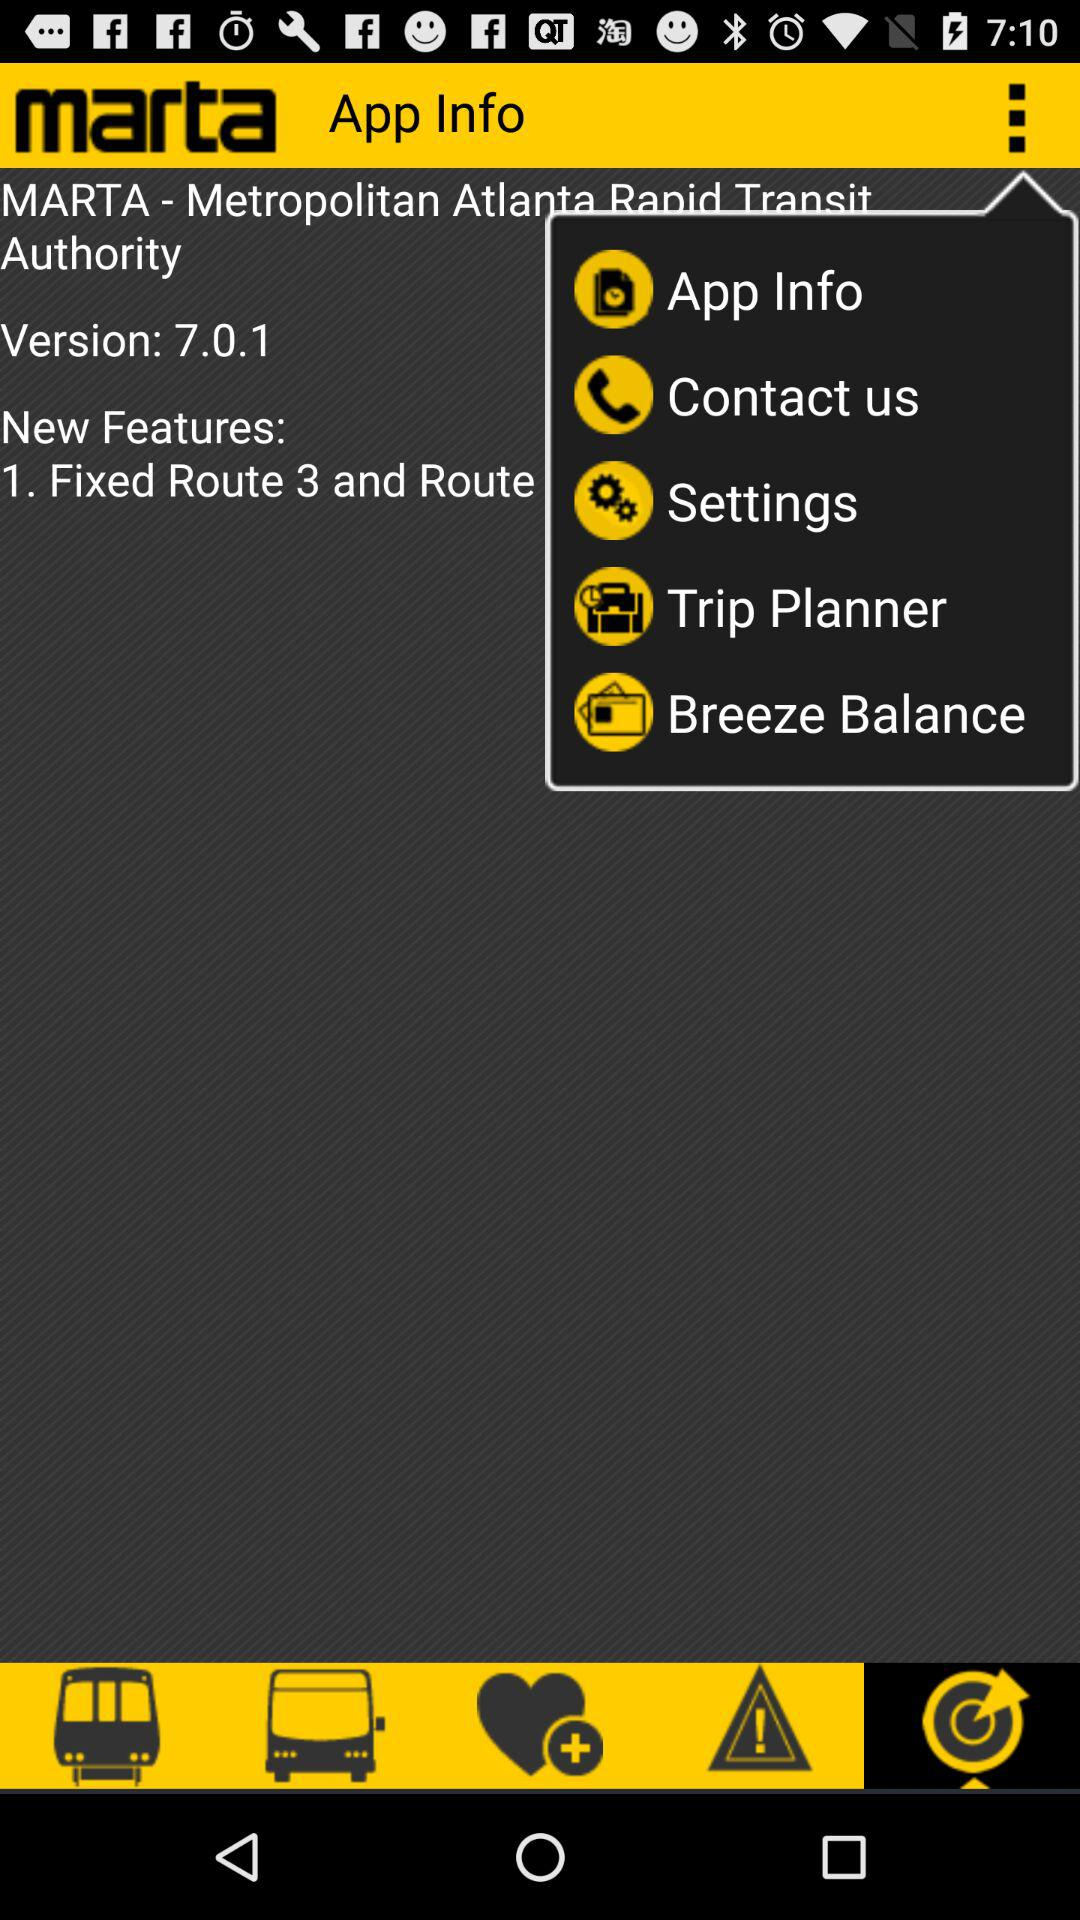What are the new features? The new feature is "Fixed Route 3 and Route". 